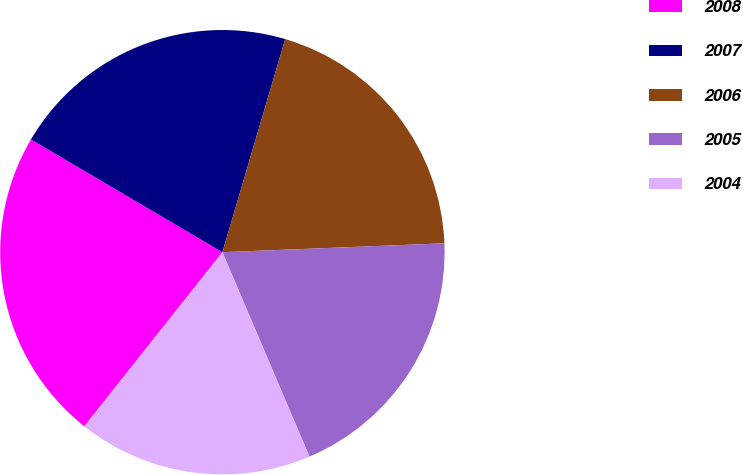<chart> <loc_0><loc_0><loc_500><loc_500><pie_chart><fcel>2008<fcel>2007<fcel>2006<fcel>2005<fcel>2004<nl><fcel>22.8%<fcel>21.09%<fcel>19.8%<fcel>19.23%<fcel>17.08%<nl></chart> 